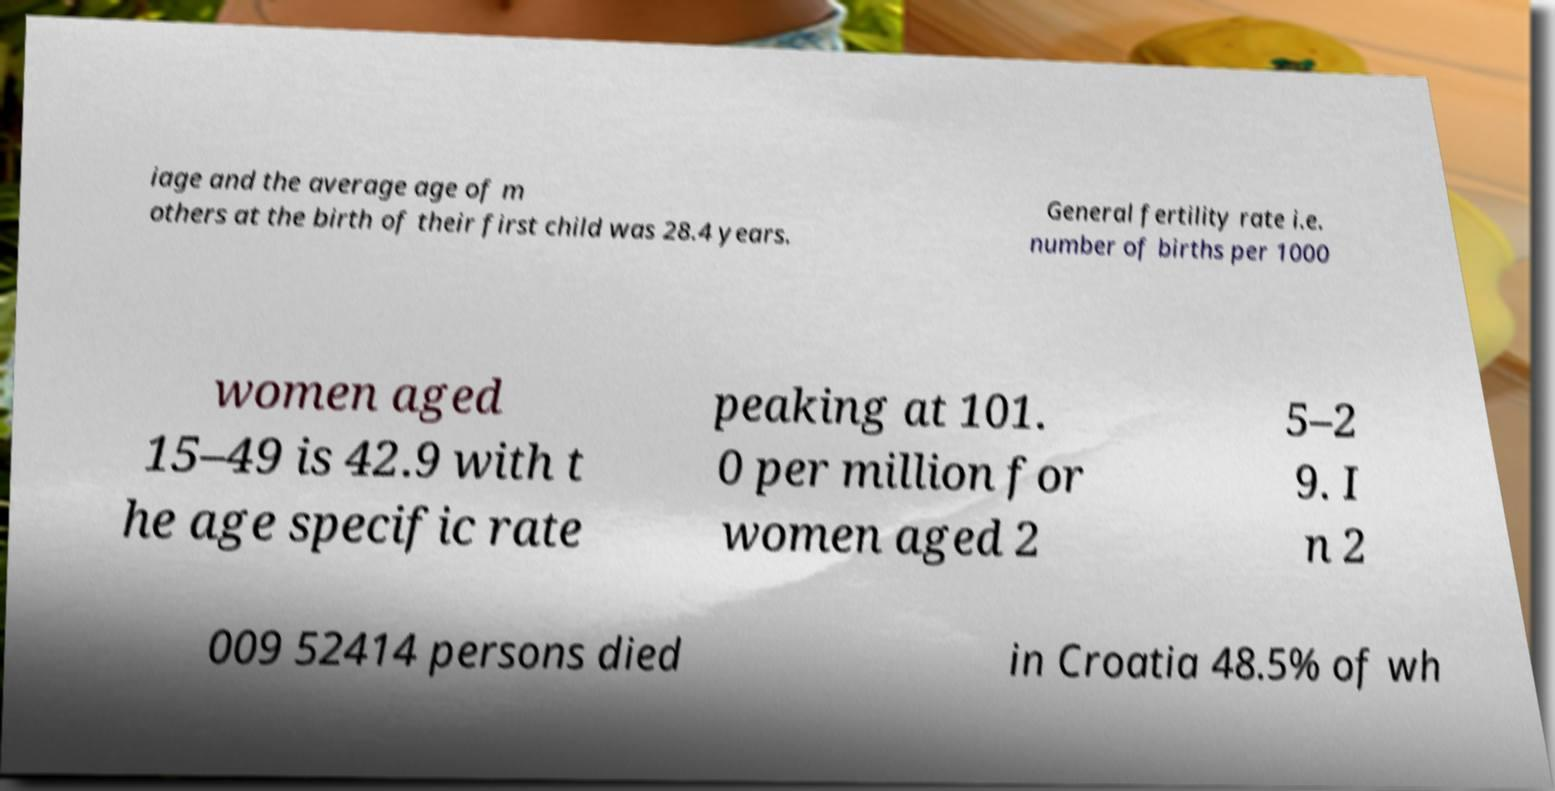Please read and relay the text visible in this image. What does it say? iage and the average age of m others at the birth of their first child was 28.4 years. General fertility rate i.e. number of births per 1000 women aged 15–49 is 42.9 with t he age specific rate peaking at 101. 0 per million for women aged 2 5–2 9. I n 2 009 52414 persons died in Croatia 48.5% of wh 